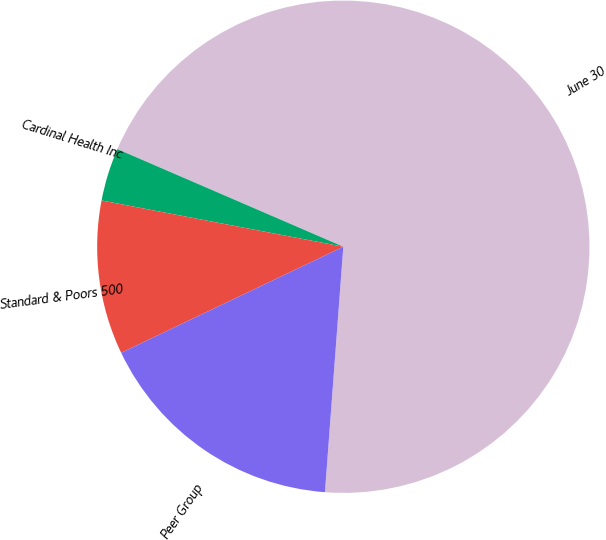Convert chart to OTSL. <chart><loc_0><loc_0><loc_500><loc_500><pie_chart><fcel>June 30<fcel>Cardinal Health Inc<fcel>Standard & Poors 500<fcel>Peer Group<nl><fcel>69.7%<fcel>3.48%<fcel>10.1%<fcel>16.72%<nl></chart> 